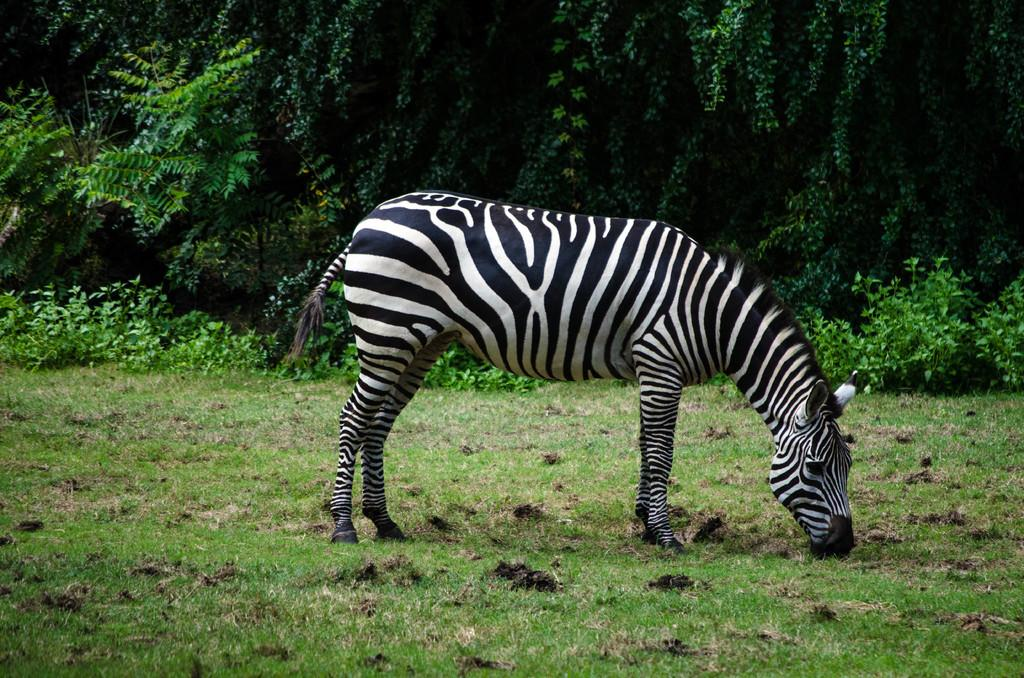What animal is in the center of the image? There is a zebra in the center of the image. What can be seen in the background of the image? There are trees in the background of the image. What type of surface is visible at the bottom of the image? There is ground visible at the bottom of the image. What statement does the zebra make in the image? The image does not depict the zebra making any statements, as it is a photograph and not a conversation. 